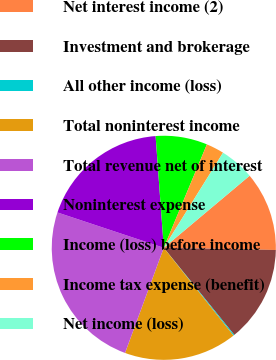<chart> <loc_0><loc_0><loc_500><loc_500><pie_chart><fcel>Net interest income (2)<fcel>Investment and brokerage<fcel>All other income (loss)<fcel>Total noninterest income<fcel>Total revenue net of interest<fcel>Noninterest expense<fcel>Income (loss) before income<fcel>Income tax expense (benefit)<fcel>Net income (loss)<nl><fcel>11.43%<fcel>13.86%<fcel>0.15%<fcel>16.3%<fcel>24.49%<fcel>18.73%<fcel>7.45%<fcel>2.58%<fcel>5.02%<nl></chart> 